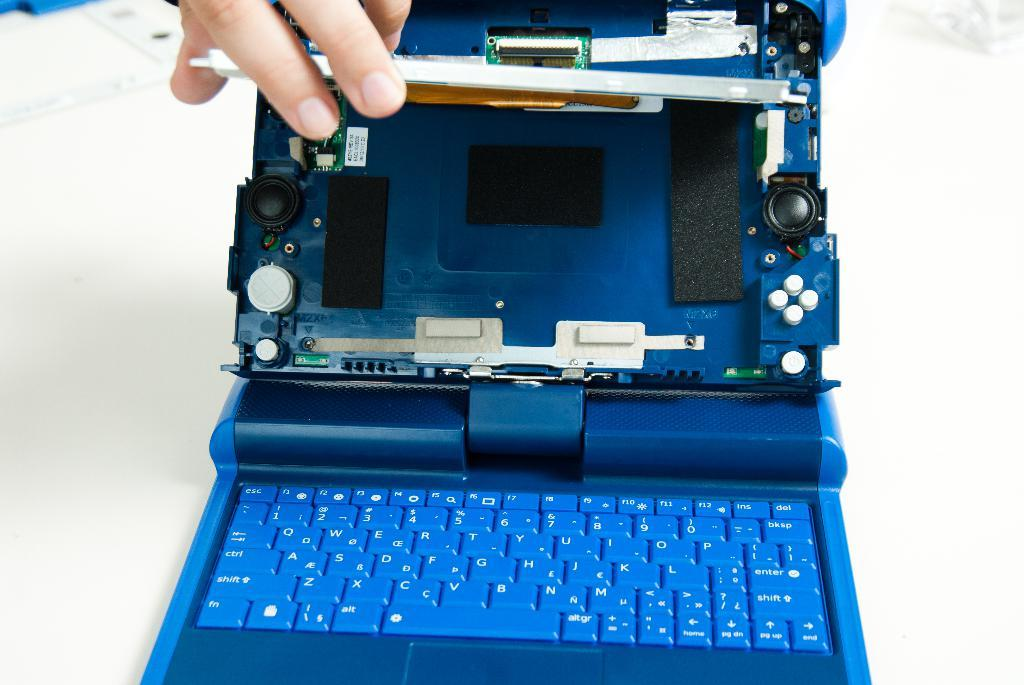<image>
Give a short and clear explanation of the subsequent image. A person opens a small portable computer that has a QWERTY keyboard. 